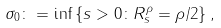<formula> <loc_0><loc_0><loc_500><loc_500>\sigma _ { 0 } \colon = \inf \left \{ s > 0 \colon R ^ { \rho } _ { s } = \rho / 2 \right \} ,</formula> 